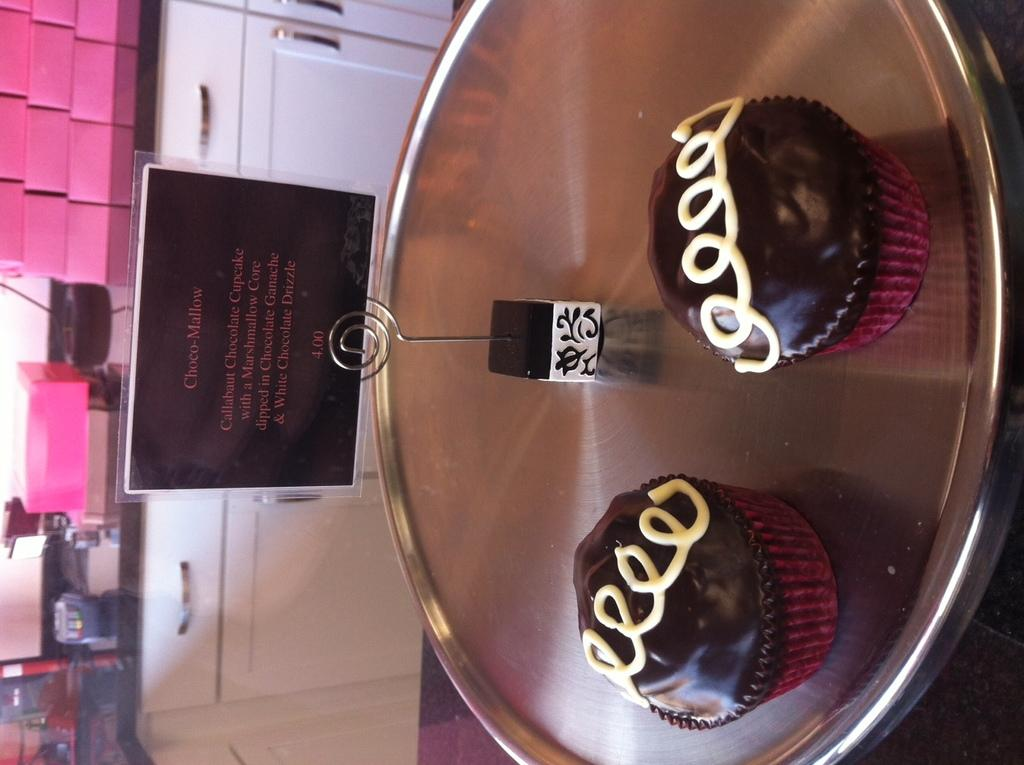<image>
Provide a brief description of the given image. Two cupcakes sit on a metal platter with a sign that identifies them as Choco-Mallow. 